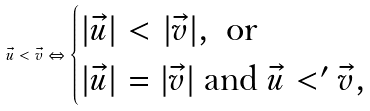<formula> <loc_0><loc_0><loc_500><loc_500>\vec { u } < \vec { v } \Leftrightarrow \begin{cases} | \vec { u } | < | \vec { v } | , \ \text {or} \\ | \vec { u } | = | \vec { v } | \ \text {and} \ \vec { u } < ^ { \prime } \vec { v } , \end{cases}</formula> 